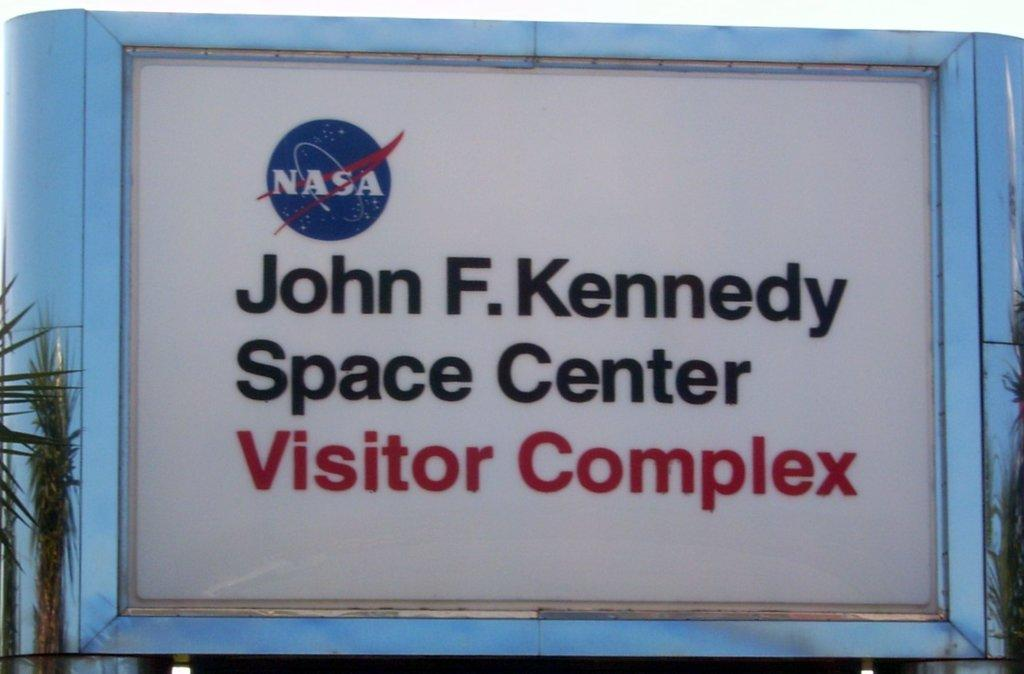Provide a one-sentence caption for the provided image. Sign mentions from Nasa that it is the John F. Kennedy Space Center Visitor Complex. 